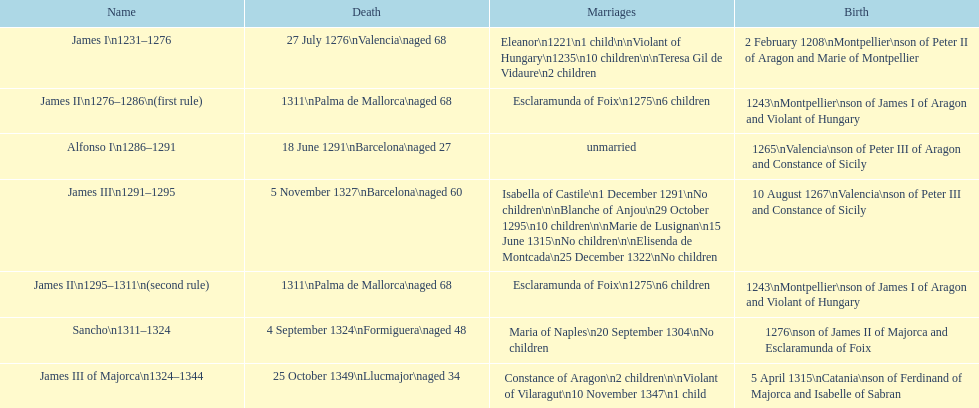Can you parse all the data within this table? {'header': ['Name', 'Death', 'Marriages', 'Birth'], 'rows': [['James I\\n1231–1276', '27 July 1276\\nValencia\\naged 68', 'Eleanor\\n1221\\n1 child\\n\\nViolant of Hungary\\n1235\\n10 children\\n\\nTeresa Gil de Vidaure\\n2 children', '2 February 1208\\nMontpellier\\nson of Peter II of Aragon and Marie of Montpellier'], ['James II\\n1276–1286\\n(first rule)', '1311\\nPalma de Mallorca\\naged 68', 'Esclaramunda of Foix\\n1275\\n6 children', '1243\\nMontpellier\\nson of James I of Aragon and Violant of Hungary'], ['Alfonso I\\n1286–1291', '18 June 1291\\nBarcelona\\naged 27', 'unmarried', '1265\\nValencia\\nson of Peter III of Aragon and Constance of Sicily'], ['James III\\n1291–1295', '5 November 1327\\nBarcelona\\naged 60', 'Isabella of Castile\\n1 December 1291\\nNo children\\n\\nBlanche of Anjou\\n29 October 1295\\n10 children\\n\\nMarie de Lusignan\\n15 June 1315\\nNo children\\n\\nElisenda de Montcada\\n25 December 1322\\nNo children', '10 August 1267\\nValencia\\nson of Peter III and Constance of Sicily'], ['James II\\n1295–1311\\n(second rule)', '1311\\nPalma de Mallorca\\naged 68', 'Esclaramunda of Foix\\n1275\\n6 children', '1243\\nMontpellier\\nson of James I of Aragon and Violant of Hungary'], ['Sancho\\n1311–1324', '4 September 1324\\nFormiguera\\naged 48', 'Maria of Naples\\n20 September 1304\\nNo children', '1276\\nson of James II of Majorca and Esclaramunda of Foix'], ['James III of Majorca\\n1324–1344', '25 October 1349\\nLlucmajor\\naged 34', 'Constance of Aragon\\n2 children\\n\\nViolant of Vilaragut\\n10 November 1347\\n1 child', '5 April 1315\\nCatania\\nson of Ferdinand of Majorca and Isabelle of Sabran']]} Which two monarchs had no children? Alfonso I, Sancho. 